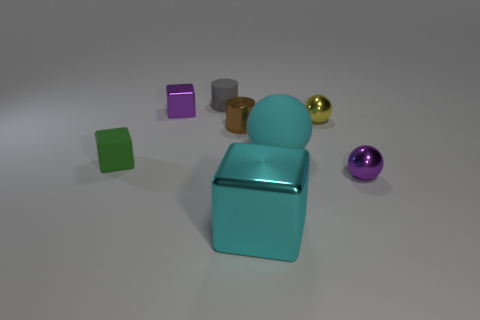What shape is the cyan object that is the same material as the small green cube?
Your answer should be compact. Sphere. Does the purple metal object in front of the purple metallic block have the same size as the purple metal thing behind the small rubber cube?
Provide a succinct answer. Yes. Is the number of small metal blocks to the left of the small shiny cube greater than the number of large cyan metal things that are behind the yellow metal sphere?
Your answer should be compact. No. How many other things are the same color as the rubber cube?
Give a very brief answer. 0. Does the tiny shiny cylinder have the same color as the cube in front of the small green rubber thing?
Give a very brief answer. No. How many small blocks are right of the tiny shiny object in front of the small matte cube?
Your answer should be very brief. 0. Is there any other thing that is the same material as the green block?
Your answer should be compact. Yes. What material is the purple object that is left of the matte sphere behind the purple object on the right side of the tiny brown metal thing made of?
Provide a succinct answer. Metal. What is the object that is both to the right of the brown shiny cylinder and behind the brown shiny cylinder made of?
Provide a short and direct response. Metal. What number of tiny purple metallic things are the same shape as the gray matte object?
Ensure brevity in your answer.  0. 